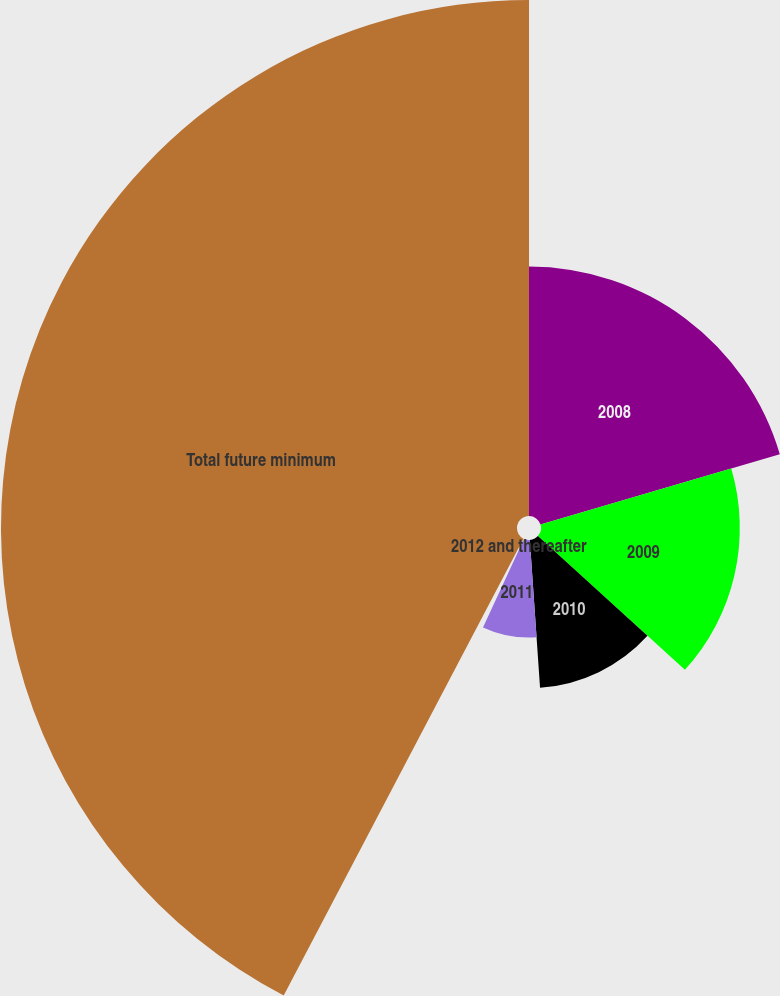Convert chart. <chart><loc_0><loc_0><loc_500><loc_500><pie_chart><fcel>2008<fcel>2009<fcel>2010<fcel>2011<fcel>2012 and thereafter<fcel>Total future minimum<nl><fcel>20.45%<fcel>16.3%<fcel>12.15%<fcel>8.0%<fcel>0.79%<fcel>42.31%<nl></chart> 